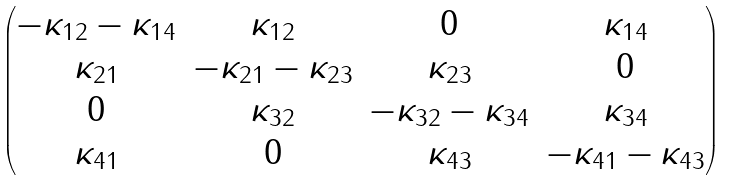Convert formula to latex. <formula><loc_0><loc_0><loc_500><loc_500>\begin{pmatrix} - \kappa _ { 1 2 } - \kappa _ { 1 4 } & \kappa _ { 1 2 } & 0 & \kappa _ { 1 4 } \\ \kappa _ { 2 1 } & - \kappa _ { 2 1 } - \kappa _ { 2 3 } & \kappa _ { 2 3 } & 0 \\ 0 & \kappa _ { 3 2 } & - \kappa _ { 3 2 } - \kappa _ { 3 4 } & \kappa _ { 3 4 } \\ \kappa _ { 4 1 } & 0 & \kappa _ { 4 3 } & - \kappa _ { 4 1 } - \kappa _ { 4 3 } \end{pmatrix}</formula> 